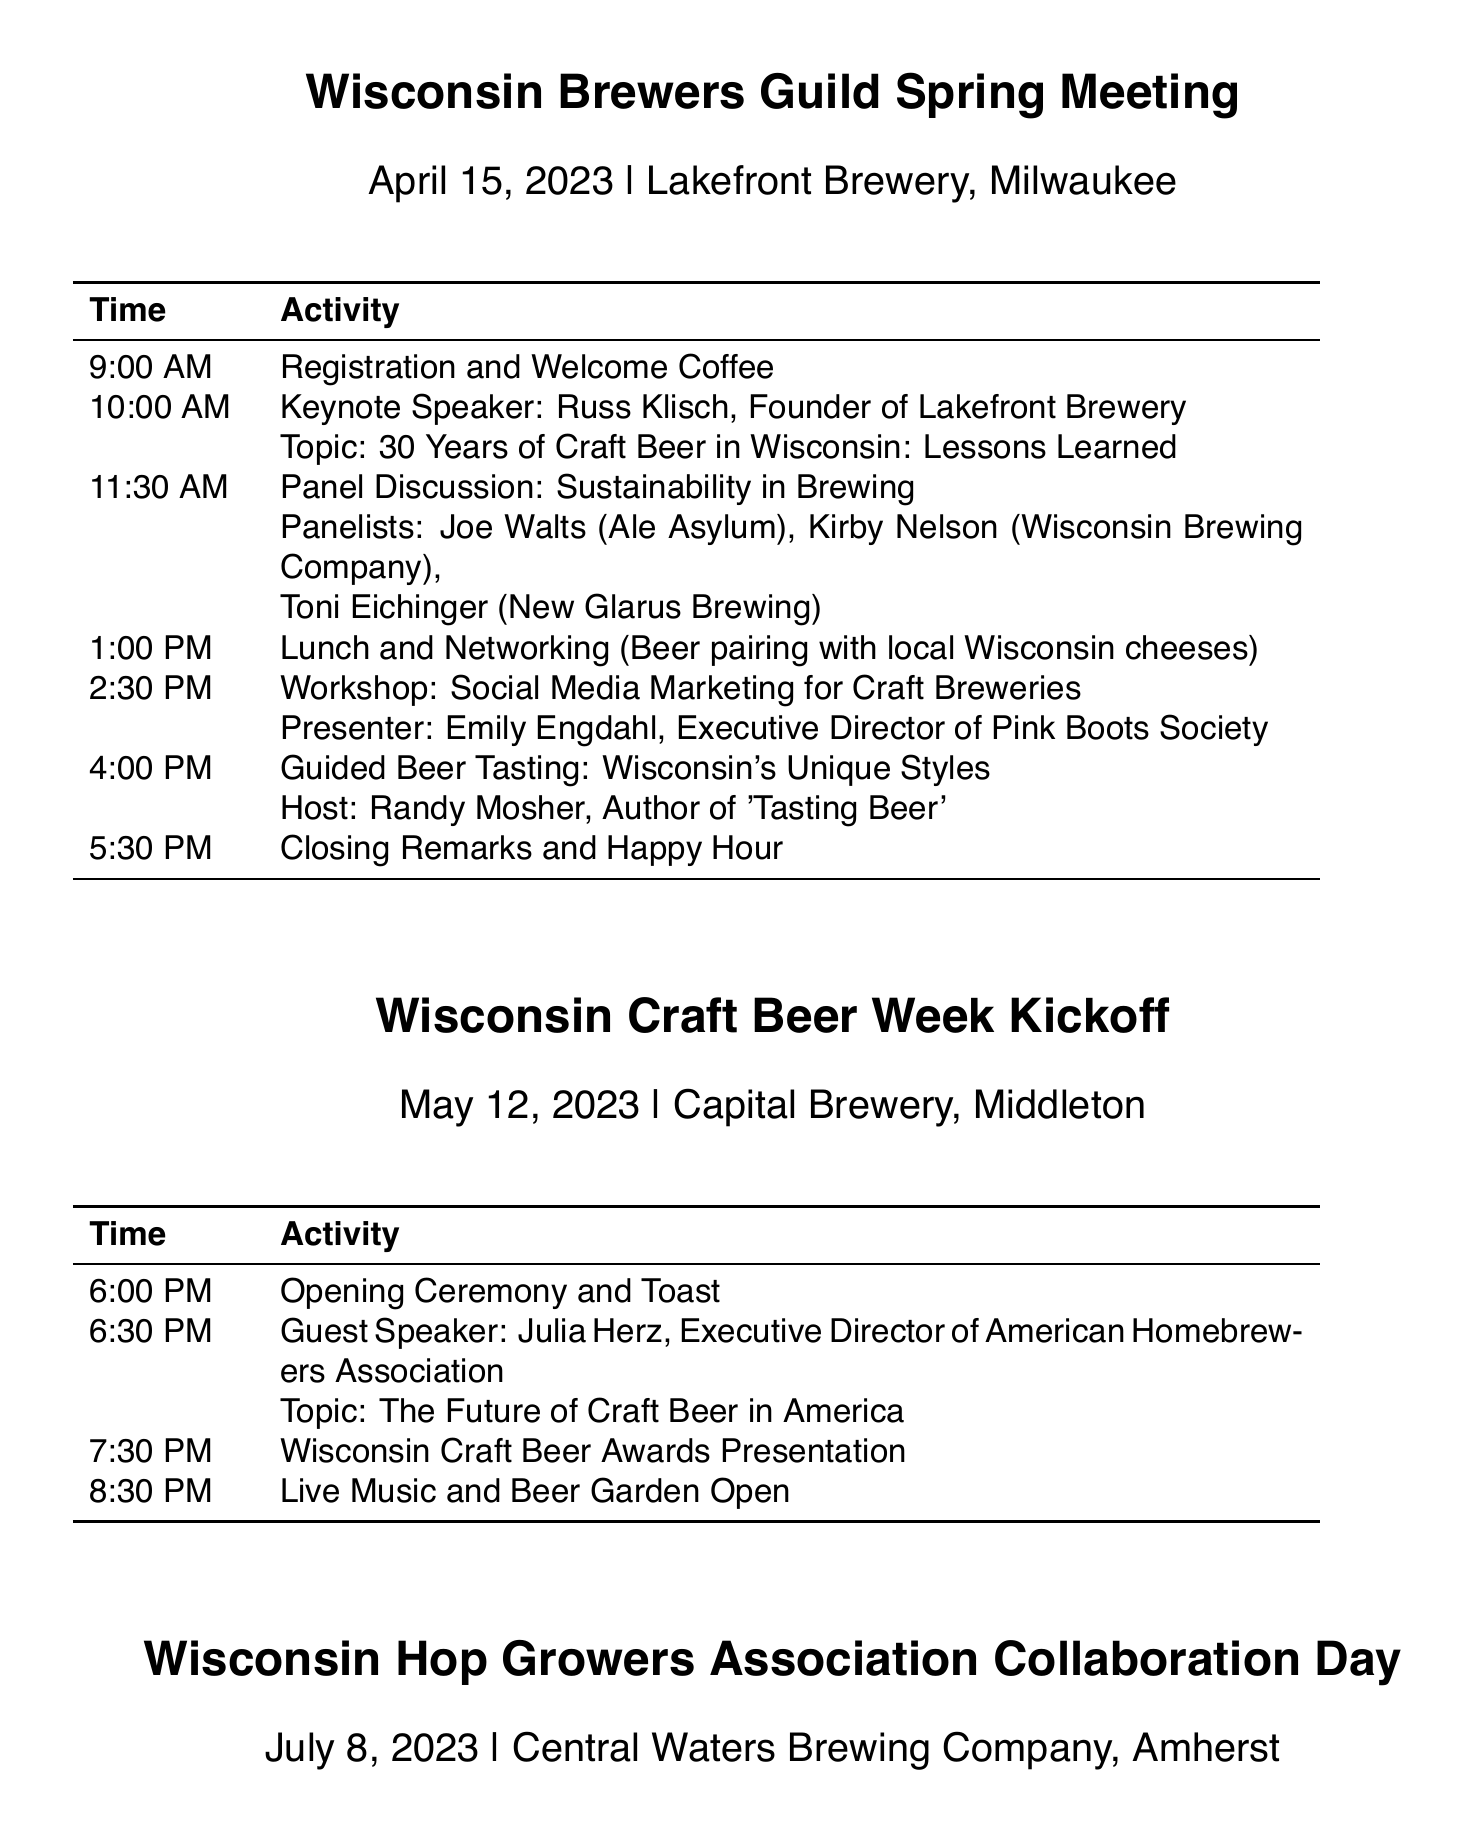What is the date of the Wisconsin Brewers Guild Spring Meeting? The date is specifically mentioned under the event name, providing the exact schedule.
Answer: April 15, 2023 Who is the keynote speaker at the Spring Meeting? The document lists the keynote speaker along with their affiliation and topic directly under the schedule of the event.
Answer: Russ Klisch What is the location of the Wisconsin Craft Beer Week Kickoff? The location is stated clearly with the event name and date in the document.
Answer: Capital Brewery, Middleton What topic will Julia Herz speak on during the Craft Beer Week Kickoff? The document specifies the topic as part of the guest speaker's introduction.
Answer: The Future of Craft Beer in America How many panelists are featured in the Sustainability in Brewing discussion? The number of panelists can be deduced from the names listed under the activity in the schedule.
Answer: Three What time does the Workshop on Social Media Marketing for Craft Breweries start? The schedule provides the exact time for the workshop under the Spring Meeting event.
Answer: 2:30 PM Who are the participants in the Collaborative Brew Session? The document lists the names of all the participants involved in this specific collaborative session.
Answer: Anello Mollica, David Oldenburg, Roxanne Andersen What is the theme for the dinner at the Fall Conference? The theme for the dinner is mentioned at the end of the Fall Conference schedule in the document.
Answer: Oktoberfest-themed Dinner What kind of beer tasting is hosted by Randy Mosher? The document describes the type of tasting as part of the activity in the schedule for the Spring Meeting.
Answer: Wisconsin's Unique Styles 